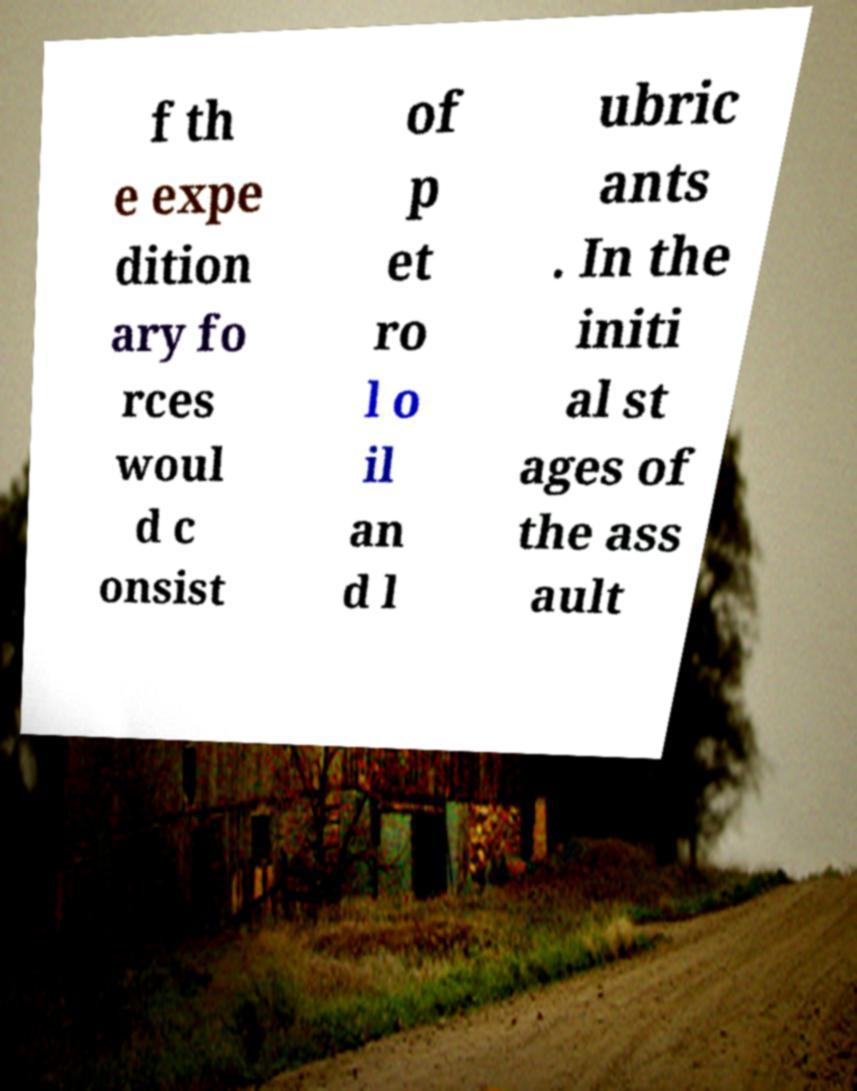Can you accurately transcribe the text from the provided image for me? f th e expe dition ary fo rces woul d c onsist of p et ro l o il an d l ubric ants . In the initi al st ages of the ass ault 